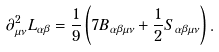Convert formula to latex. <formula><loc_0><loc_0><loc_500><loc_500>\partial ^ { 2 } _ { \mu \nu } L _ { \alpha \beta } = \frac { 1 } { 9 } \left ( 7 B _ { \alpha \beta \mu \nu } + \frac { 1 } { 2 } S _ { \alpha \beta \mu \nu } \right ) .</formula> 